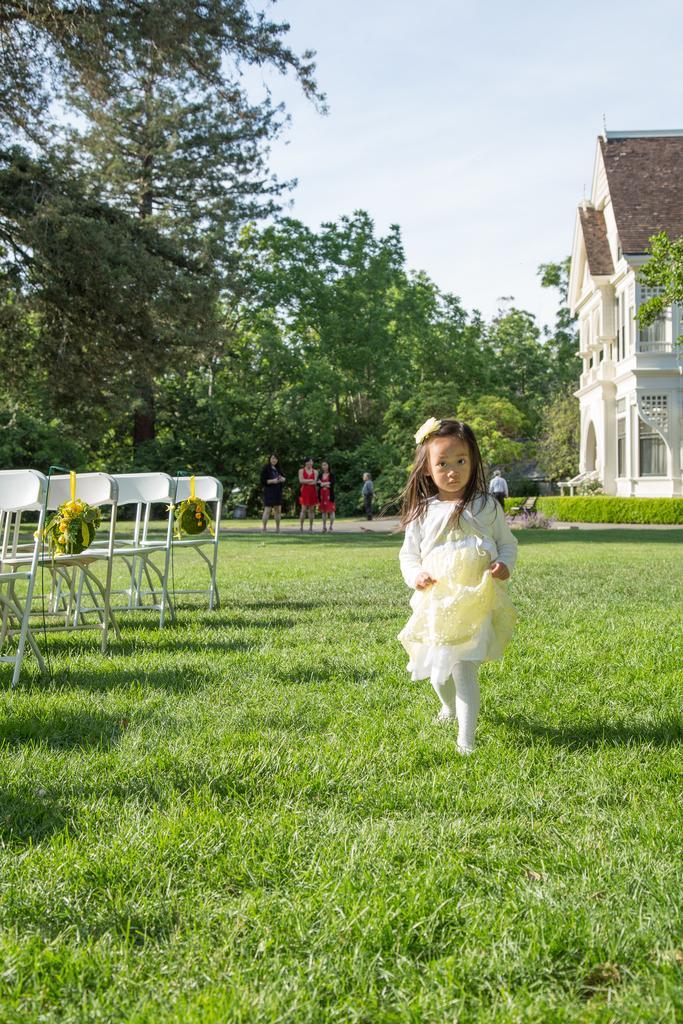Please provide a concise description of this image. In this picture there is a girl at the right side of the image walking in the grass floor, there are some people those who are standing at the left side of the image, there are some trees around the area, there is a house at the right side of the image. 